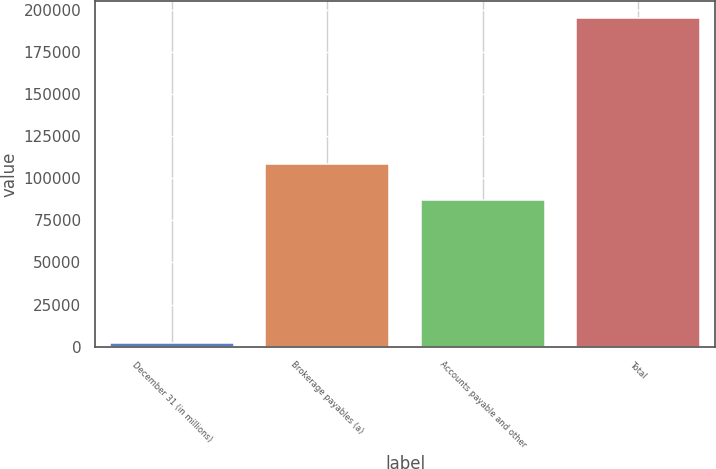Convert chart. <chart><loc_0><loc_0><loc_500><loc_500><bar_chart><fcel>December 31 (in millions)<fcel>Brokerage payables (a)<fcel>Accounts payable and other<fcel>Total<nl><fcel>2012<fcel>108398<fcel>86842<fcel>195240<nl></chart> 